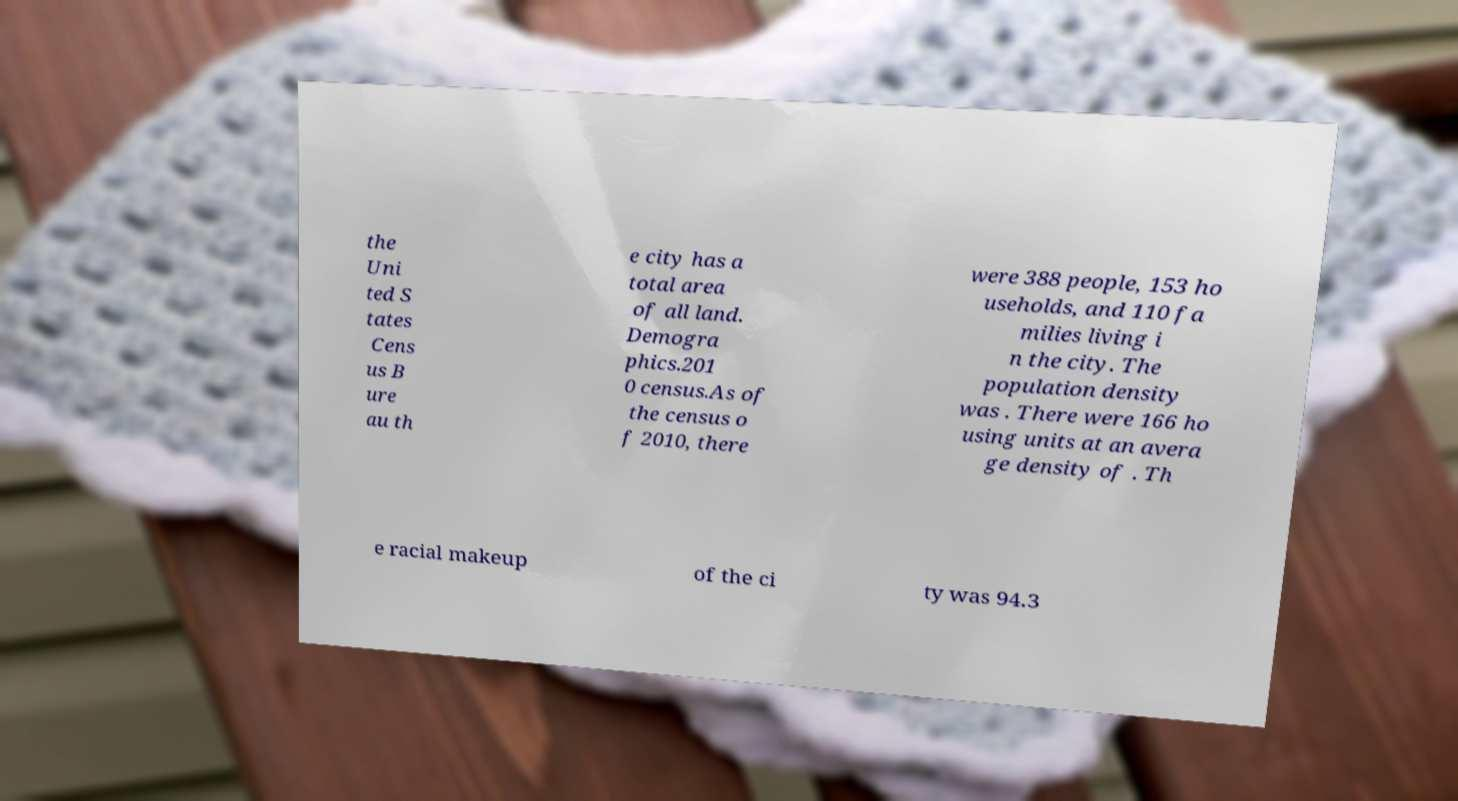For documentation purposes, I need the text within this image transcribed. Could you provide that? the Uni ted S tates Cens us B ure au th e city has a total area of all land. Demogra phics.201 0 census.As of the census o f 2010, there were 388 people, 153 ho useholds, and 110 fa milies living i n the city. The population density was . There were 166 ho using units at an avera ge density of . Th e racial makeup of the ci ty was 94.3 